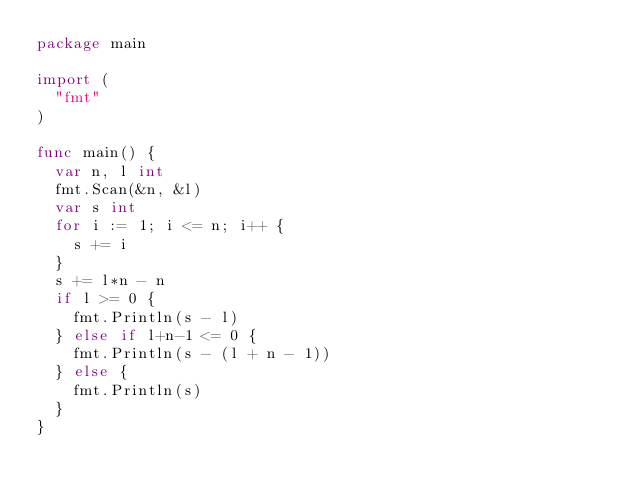Convert code to text. <code><loc_0><loc_0><loc_500><loc_500><_Go_>package main

import (
	"fmt"
)

func main() {
	var n, l int
	fmt.Scan(&n, &l)
	var s int
	for i := 1; i <= n; i++ {
		s += i
	}
	s += l*n - n
	if l >= 0 {
		fmt.Println(s - l)
	} else if l+n-1 <= 0 {
		fmt.Println(s - (l + n - 1))
	} else {
		fmt.Println(s)
	}
}
</code> 